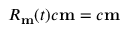Convert formula to latex. <formula><loc_0><loc_0><loc_500><loc_500>R _ { m } ( t ) c { m } = c { m }</formula> 